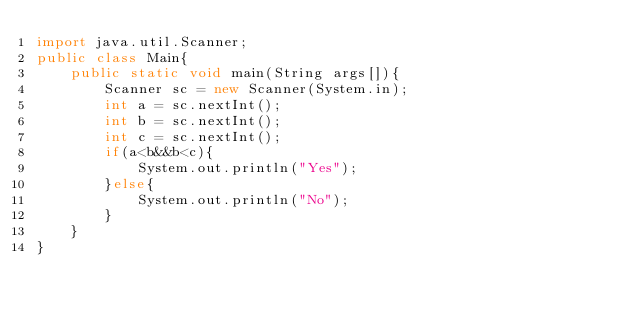<code> <loc_0><loc_0><loc_500><loc_500><_Java_>import java.util.Scanner;
public class Main{
    public static void main(String args[]){
        Scanner sc = new Scanner(System.in);
        int a = sc.nextInt();
        int b = sc.nextInt();
        int c = sc.nextInt();
        if(a<b&&b<c){
            System.out.println("Yes");
        }else{
            System.out.println("No");
        }
    }
}
</code> 